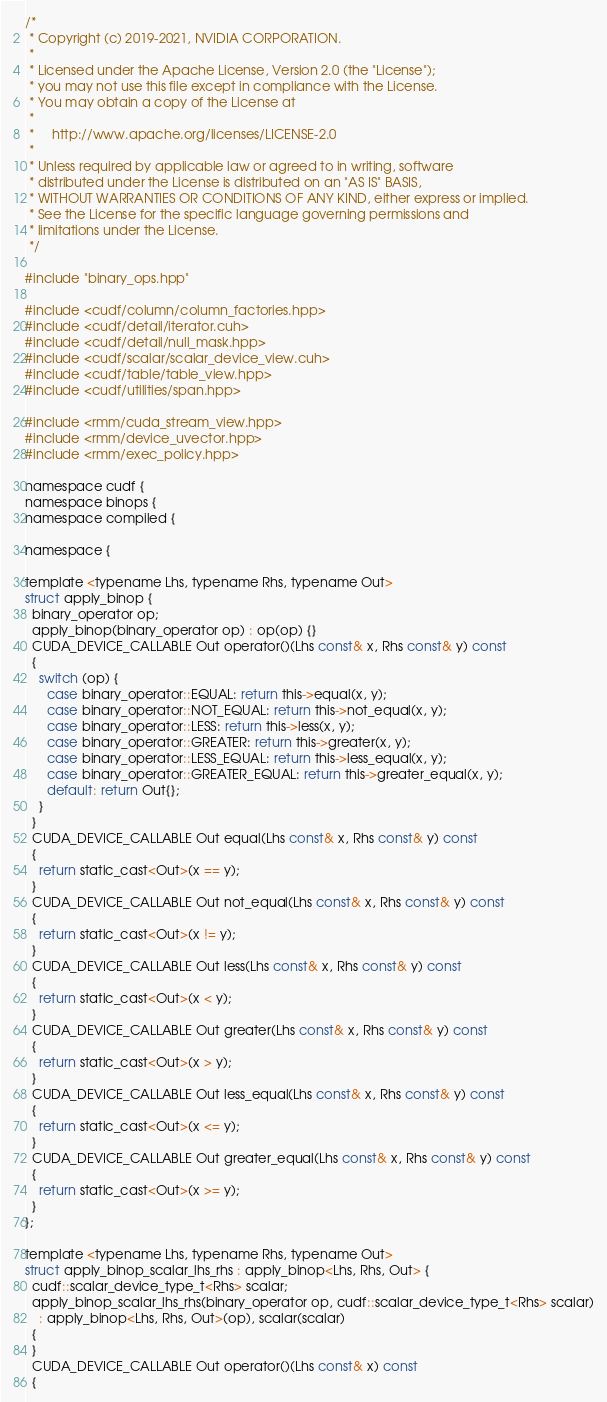<code> <loc_0><loc_0><loc_500><loc_500><_Cuda_>/*
 * Copyright (c) 2019-2021, NVIDIA CORPORATION.
 *
 * Licensed under the Apache License, Version 2.0 (the "License");
 * you may not use this file except in compliance with the License.
 * You may obtain a copy of the License at
 *
 *     http://www.apache.org/licenses/LICENSE-2.0
 *
 * Unless required by applicable law or agreed to in writing, software
 * distributed under the License is distributed on an "AS IS" BASIS,
 * WITHOUT WARRANTIES OR CONDITIONS OF ANY KIND, either express or implied.
 * See the License for the specific language governing permissions and
 * limitations under the License.
 */

#include "binary_ops.hpp"

#include <cudf/column/column_factories.hpp>
#include <cudf/detail/iterator.cuh>
#include <cudf/detail/null_mask.hpp>
#include <cudf/scalar/scalar_device_view.cuh>
#include <cudf/table/table_view.hpp>
#include <cudf/utilities/span.hpp>

#include <rmm/cuda_stream_view.hpp>
#include <rmm/device_uvector.hpp>
#include <rmm/exec_policy.hpp>

namespace cudf {
namespace binops {
namespace compiled {

namespace {

template <typename Lhs, typename Rhs, typename Out>
struct apply_binop {
  binary_operator op;
  apply_binop(binary_operator op) : op(op) {}
  CUDA_DEVICE_CALLABLE Out operator()(Lhs const& x, Rhs const& y) const
  {
    switch (op) {
      case binary_operator::EQUAL: return this->equal(x, y);
      case binary_operator::NOT_EQUAL: return this->not_equal(x, y);
      case binary_operator::LESS: return this->less(x, y);
      case binary_operator::GREATER: return this->greater(x, y);
      case binary_operator::LESS_EQUAL: return this->less_equal(x, y);
      case binary_operator::GREATER_EQUAL: return this->greater_equal(x, y);
      default: return Out{};
    }
  }
  CUDA_DEVICE_CALLABLE Out equal(Lhs const& x, Rhs const& y) const
  {
    return static_cast<Out>(x == y);
  }
  CUDA_DEVICE_CALLABLE Out not_equal(Lhs const& x, Rhs const& y) const
  {
    return static_cast<Out>(x != y);
  }
  CUDA_DEVICE_CALLABLE Out less(Lhs const& x, Rhs const& y) const
  {
    return static_cast<Out>(x < y);
  }
  CUDA_DEVICE_CALLABLE Out greater(Lhs const& x, Rhs const& y) const
  {
    return static_cast<Out>(x > y);
  }
  CUDA_DEVICE_CALLABLE Out less_equal(Lhs const& x, Rhs const& y) const
  {
    return static_cast<Out>(x <= y);
  }
  CUDA_DEVICE_CALLABLE Out greater_equal(Lhs const& x, Rhs const& y) const
  {
    return static_cast<Out>(x >= y);
  }
};

template <typename Lhs, typename Rhs, typename Out>
struct apply_binop_scalar_lhs_rhs : apply_binop<Lhs, Rhs, Out> {
  cudf::scalar_device_type_t<Rhs> scalar;
  apply_binop_scalar_lhs_rhs(binary_operator op, cudf::scalar_device_type_t<Rhs> scalar)
    : apply_binop<Lhs, Rhs, Out>(op), scalar(scalar)
  {
  }
  CUDA_DEVICE_CALLABLE Out operator()(Lhs const& x) const
  {</code> 